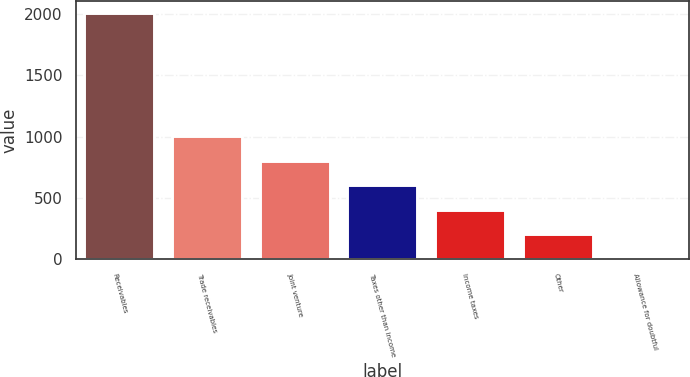Convert chart. <chart><loc_0><loc_0><loc_500><loc_500><bar_chart><fcel>Receivables<fcel>Trade receivables<fcel>Joint venture<fcel>Taxes other than income<fcel>Income taxes<fcel>Other<fcel>Allowance for doubtful<nl><fcel>2003<fcel>1003.9<fcel>804.08<fcel>604.26<fcel>404.44<fcel>204.62<fcel>4.8<nl></chart> 